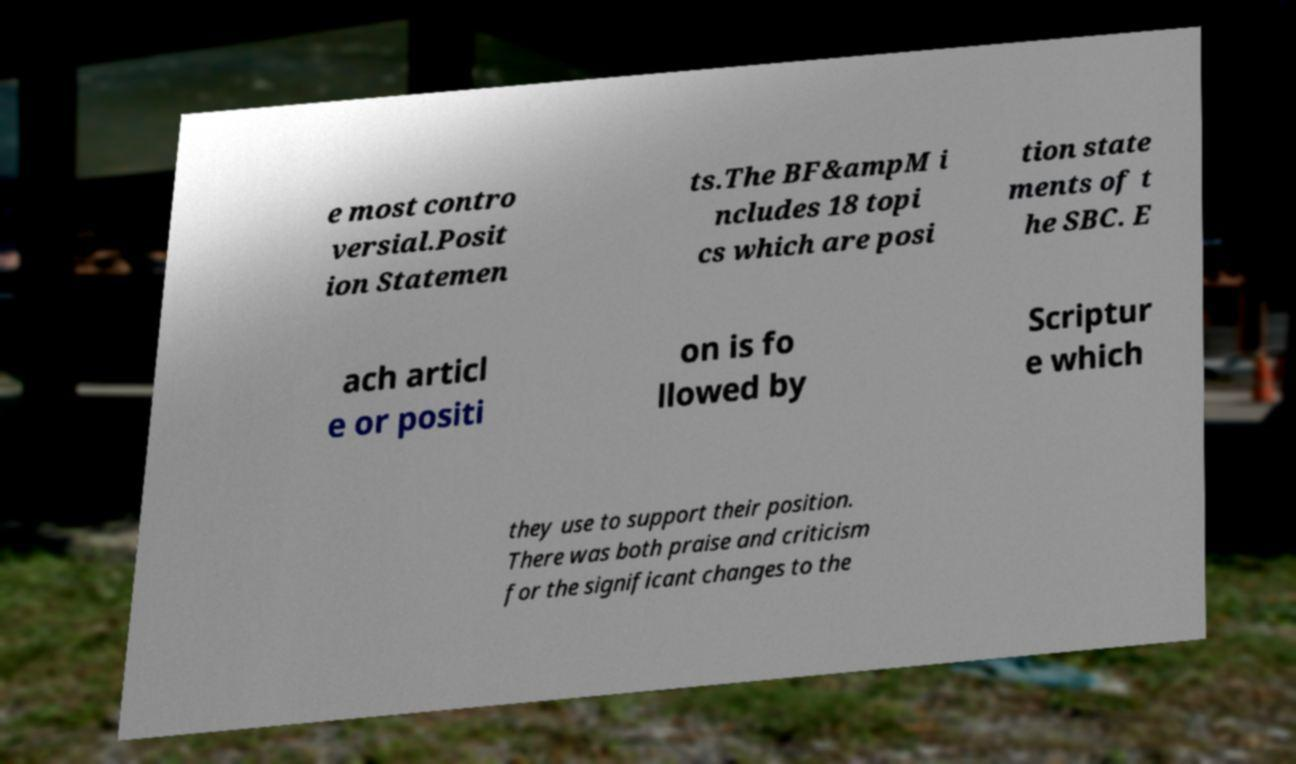Can you accurately transcribe the text from the provided image for me? e most contro versial.Posit ion Statemen ts.The BF&ampM i ncludes 18 topi cs which are posi tion state ments of t he SBC. E ach articl e or positi on is fo llowed by Scriptur e which they use to support their position. There was both praise and criticism for the significant changes to the 